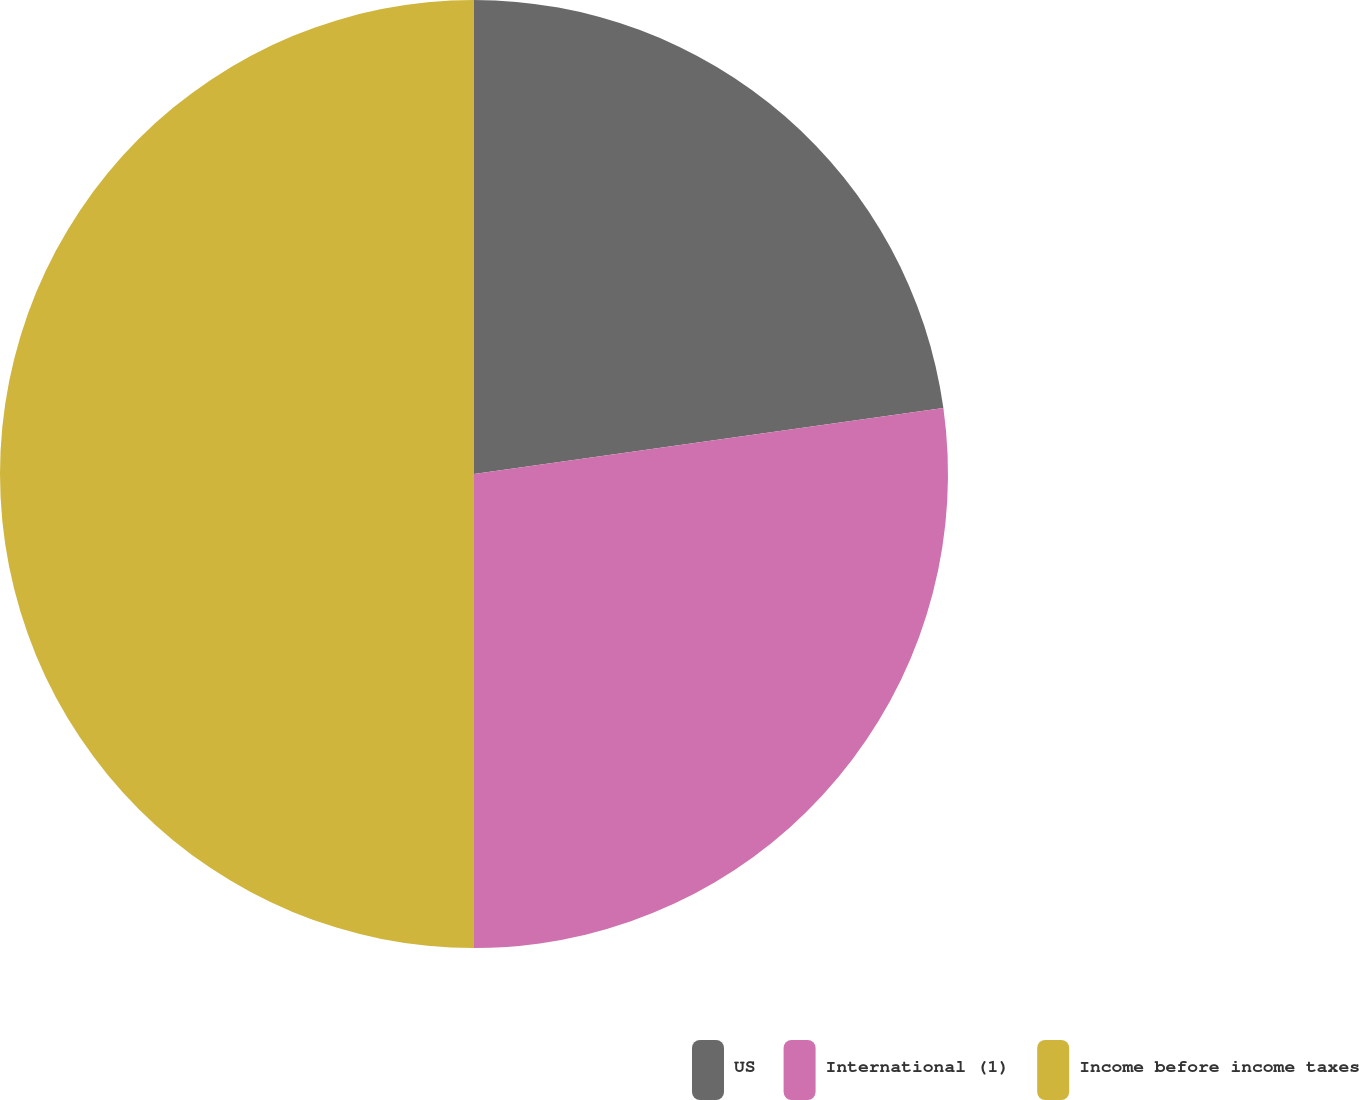Convert chart. <chart><loc_0><loc_0><loc_500><loc_500><pie_chart><fcel>US<fcel>International (1)<fcel>Income before income taxes<nl><fcel>22.78%<fcel>27.22%<fcel>50.0%<nl></chart> 